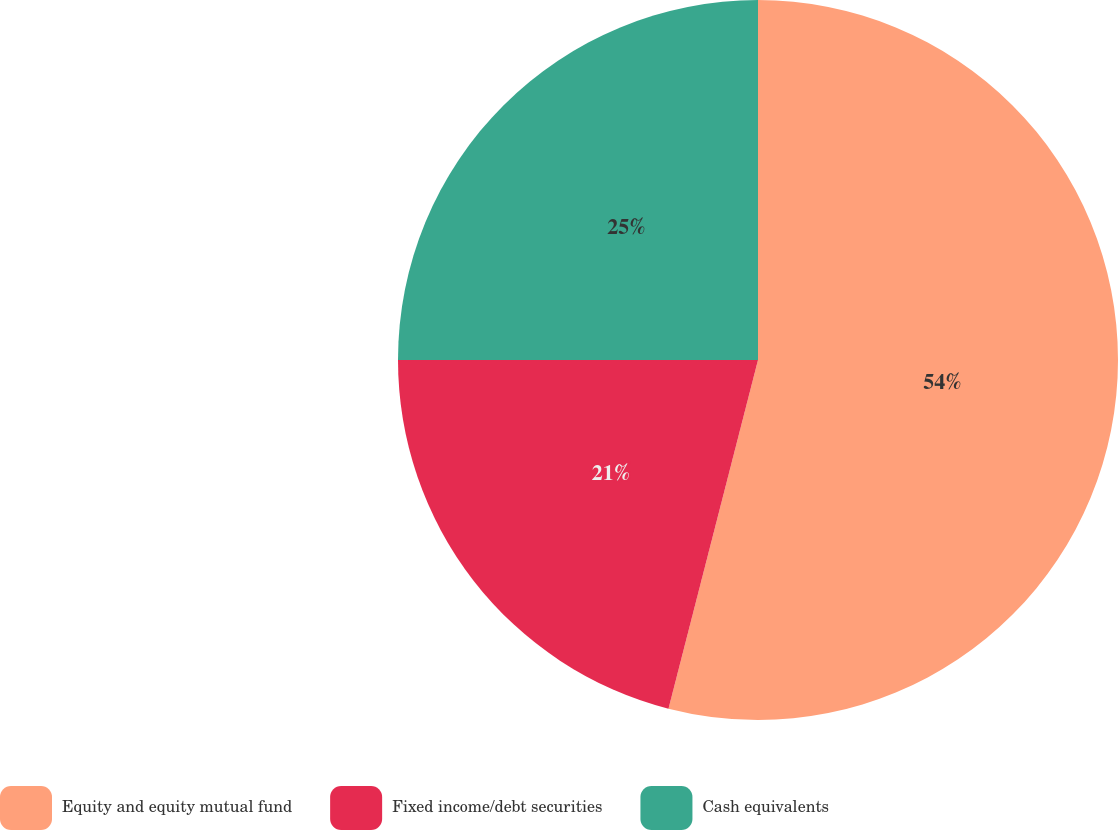Convert chart to OTSL. <chart><loc_0><loc_0><loc_500><loc_500><pie_chart><fcel>Equity and equity mutual fund<fcel>Fixed income/debt securities<fcel>Cash equivalents<nl><fcel>54.0%<fcel>21.0%<fcel>25.0%<nl></chart> 